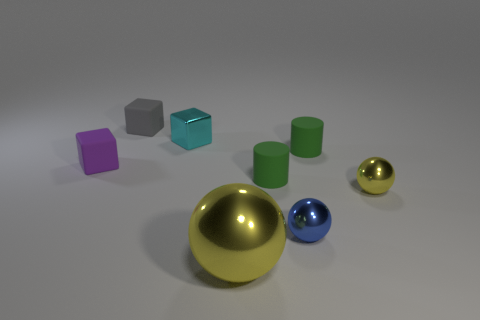Subtract all tiny blue balls. How many balls are left? 2 Subtract all green cylinders. How many yellow spheres are left? 2 Subtract 3 spheres. How many spheres are left? 0 Subtract all blue balls. How many balls are left? 2 Add 2 green matte balls. How many objects exist? 10 Subtract all cyan balls. Subtract all yellow blocks. How many balls are left? 3 Subtract all cyan metal objects. Subtract all gray blocks. How many objects are left? 6 Add 3 blue shiny balls. How many blue shiny balls are left? 4 Add 8 yellow rubber things. How many yellow rubber things exist? 8 Subtract 0 brown cylinders. How many objects are left? 8 